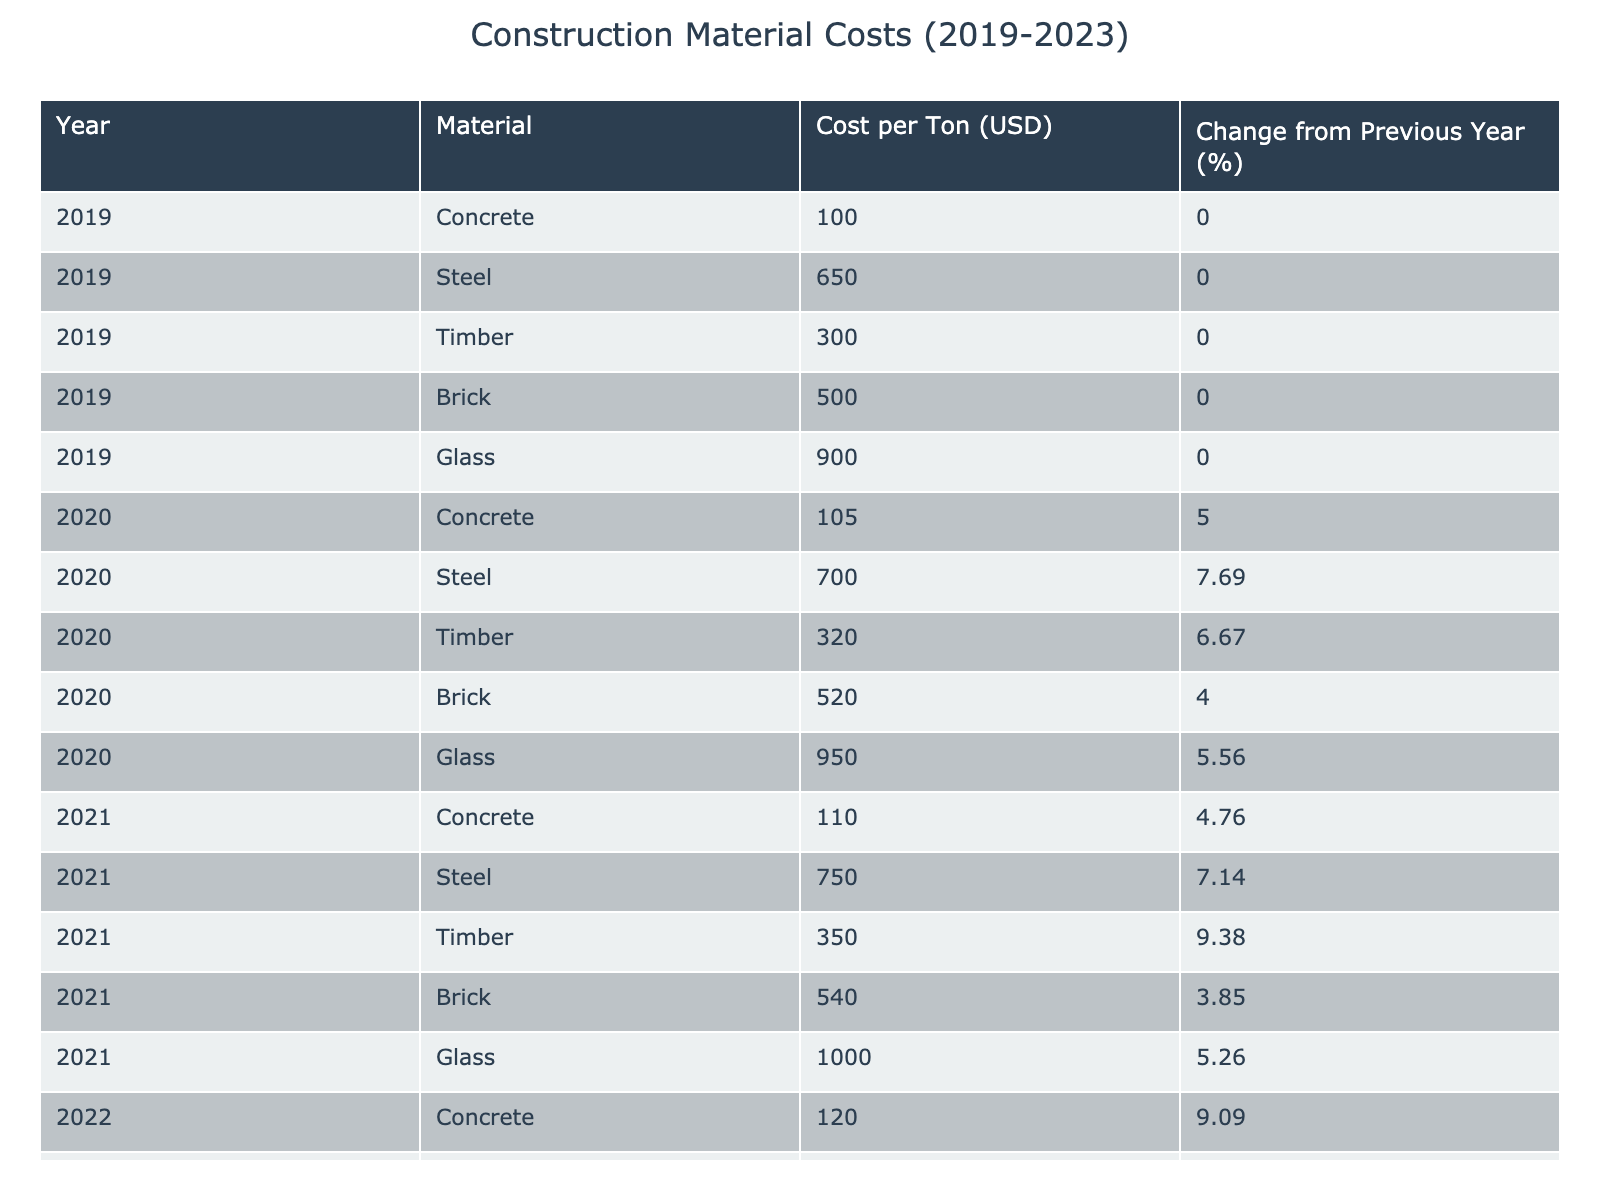What was the cost per ton of steel in 2021? In the table, under the year 2021, the material steel shows a cost of 750 USD per ton.
Answer: 750 USD Which construction material saw the highest percentage increase in cost from 2021 to 2022? From the table, timber had a cost increase from 350 to 400 USD, which is a change of around 14.29%, the highest percentage increase from that year.
Answer: Timber What was the average cost per ton of concrete over the five years? The costs per ton of concrete are: 100, 105, 110, 120, and 130 USD. Summing these gives 100 + 105 + 110 + 120 + 130 = 565 USD. The average is 565/5 = 113 USD.
Answer: 113 USD Did the cost of glass decrease in any year during this period? Reviewing the table, the cost of glass only increased each year from 900 to 1150 USD. Therefore, there was no decrease in any year.
Answer: No What was the total percentage increase in the cost of brick from 2019 to 2023? The cost of brick increased from 500 USD in 2019 to 580 USD in 2023. To find the total increase: (580 - 500) / 500 * 100% = 16%.
Answer: 16% Which material had the lowest cost per ton in 2020? Lasting from 2020 data in the table, the costs were: Concrete 105, Steel 700, Timber 320, Brick 520, and Glass 950. Timber had the lowest cost at 320 USD per ton.
Answer: Timber What was the difference in cost per ton between glass and concrete in 2023? In 2023, the cost of glass was 1150 USD per ton, and concrete was 130 USD per ton. The difference is 1150 - 130 = 1020 USD.
Answer: 1020 USD Which material had a consistent increase in cost every year, and what was the percentage change from 2019 to 2023? Examining the materials in the table, every material increased yearly, but glass had a consistent increase each year: Cost in 2019 was 900 and in 2023 was 1150. The percentage change is (1150 - 900) / 900 * 100% = ~27.78%.
Answer: Glass, ~27.78% What was the change from previous year percentage for steel in 2020? Referring to the table for 2020, steel's change from the previous year is shown as 7.69%.
Answer: 7.69% How much did the price of timber rise each year compared to the previous one in 2022? The cost of timber in 2021 was 350 USD and it rose to 400 USD in 2022. This indicates a change of (400 - 350) / 350 * 100% = 14.29%.
Answer: 14.29% 